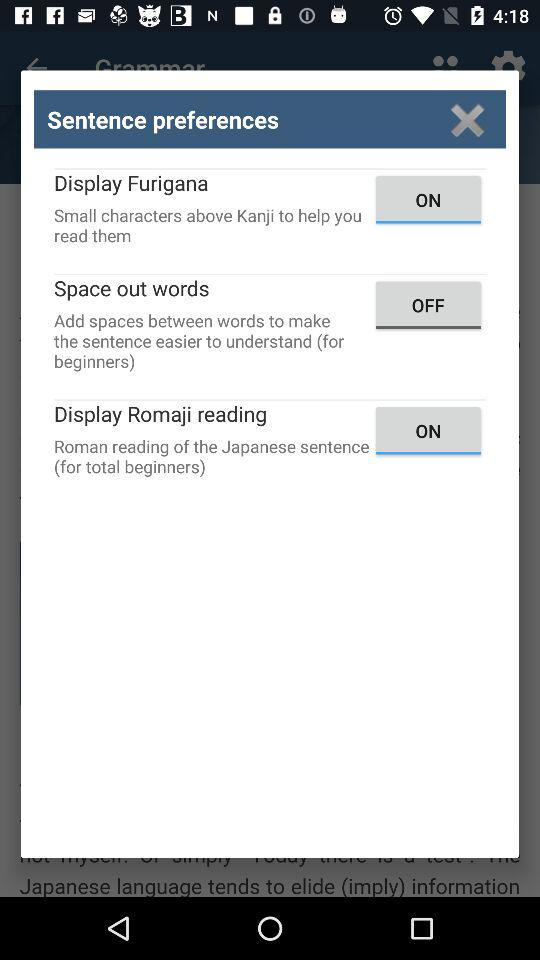What is the current status of the "Display Furigana"? The current status is "on". 